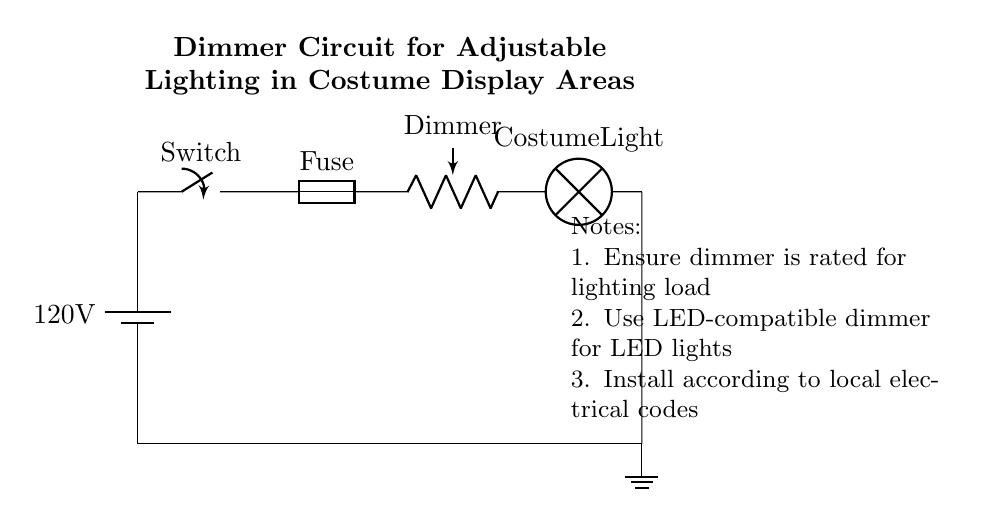What is the voltage of the battery? The battery in the circuit diagram is labeled as providing 120 volts, which is the standard voltage for household circuits.
Answer: 120 volts What component is used to adjust the brightness? The circuit diagram includes a potentiometer labeled as "Dimmer," indicating that it is the component responsible for adjusting the brightness of the lamp.
Answer: Dimmer What is the role of the fuse in this circuit? The fuse is included for protection; it prevents excessive current from flowing through the circuit, which could cause damage to components like the dimmer or the lamp.
Answer: Protection How is the circuit connected to the ground? The ground connection is indicated by a line leading to a ground symbol, showing that the circuit returns to the earth ground, providing safety against electrical faults.
Answer: Ground connection What is the purpose of the switch in this circuit? The switch allows for the control of the circuit by turning the entire system on or off, enabling or disabling the flow of current to the lamp.
Answer: Control power If a user wants to install an LED light, what should they ensure about the dimmer? The notes indicate that a user should use an LED-compatible dimmer, meaning the dimmer must be rated for use with LED lights to function correctly without flickering.
Answer: LED compatibility 